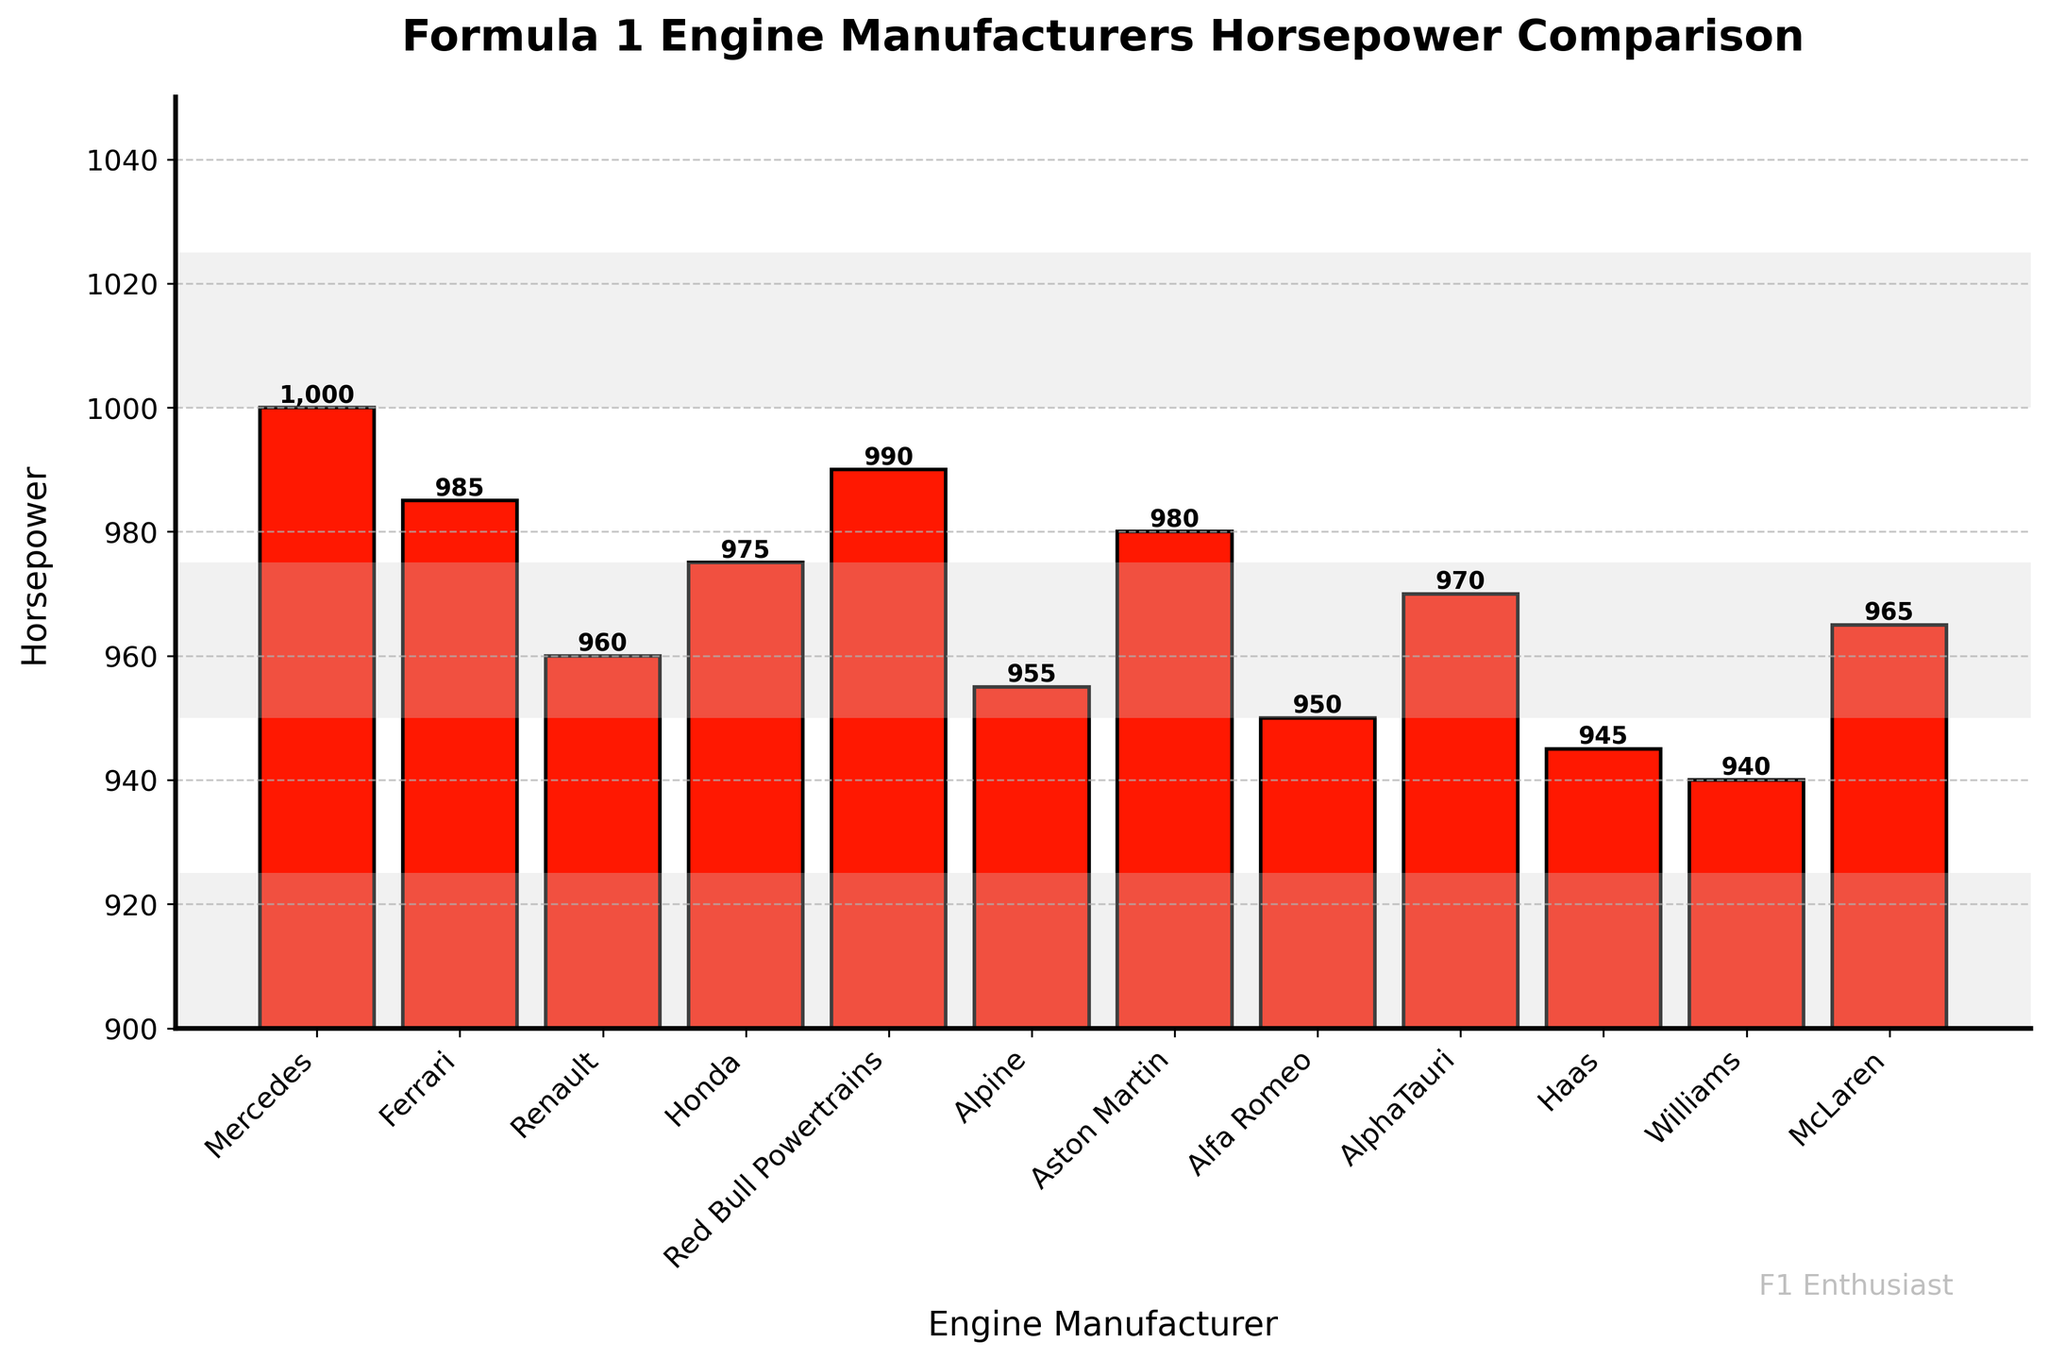Which engine manufacturer has the highest horsepower? By looking at the bar chart, the bar representing Mercedes is the tallest, indicating it has the highest horsepower.
Answer: Mercedes Which two manufacturers have the closest horsepower values? By closely inspecting the heights of the bars, Aston Martin and Ferrari have very similar heights, indicating that their horsepower values are very close.
Answer: Aston Martin and Ferrari What's the average horsepower of the manufacturers? Add up all the horsepower values (1000 + 985 + 960 + 975 + 990 + 955 + 980 + 950 + 970 + 945 + 940 + 965 = 11615) and divide by the number of manufacturers (12). The average horsepower is 11615 / 12.
Answer: 968 How much more horsepower does Mercedes have compared to the manufacturer with the lowest horsepower? Mercedes has 1000 horsepower, and Williams has the lowest at 940 horsepower. The difference is 1000 - 940.
Answer: 60 Which manufacturers have a horsepower below 960? By looking at the heights of the bars and their corresponding labels, Alfa Romeo (950), Haas (945), and Williams (940) have horsepower values below 960.
Answer: Alfa Romeo, Haas, Williams What is the difference in horsepower between Red Bull Powertrains and Renault? Red Bull Powertrains has 990 horsepower, and Renault has 960 horsepower. The difference can be calculated as 990 - 960.
Answer: 30 Are there any manufacturers with equal horsepower? By examining the bar chart, it is clear that no two bars have exactly the same height, indicating no manufacturers have equal horsepower.
Answer: No What's the total horsepower produced by Ferrari, Honda, and McLaren combined? Sum the horsepower values of Ferrari (985), Honda (975), and McLaren (965). The combined total is 985 + 975 + 965.
Answer: 2925 Which manufacturer lies exactly in the middle in terms of horsepower? When the manufacturers are sorted by horsepower, McLaren is the median since it is the 6th value of the sorted list (the list is: Williams, Haas, Alfa Romeo, Alpine, Renault, McLaren, AlphaTauri, Honda, Aston Martin, Ferrari, Red Bull Powertrains, Mercedes).
Answer: McLaren 